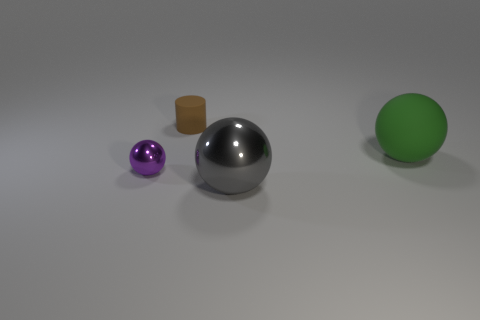What shape is the brown matte object that is the same size as the purple shiny ball? cylinder 